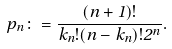<formula> <loc_0><loc_0><loc_500><loc_500>p _ { n } \colon = \frac { ( n + 1 ) ! } { k _ { n } ! ( n - k _ { n } ) ! 2 ^ { n } } .</formula> 